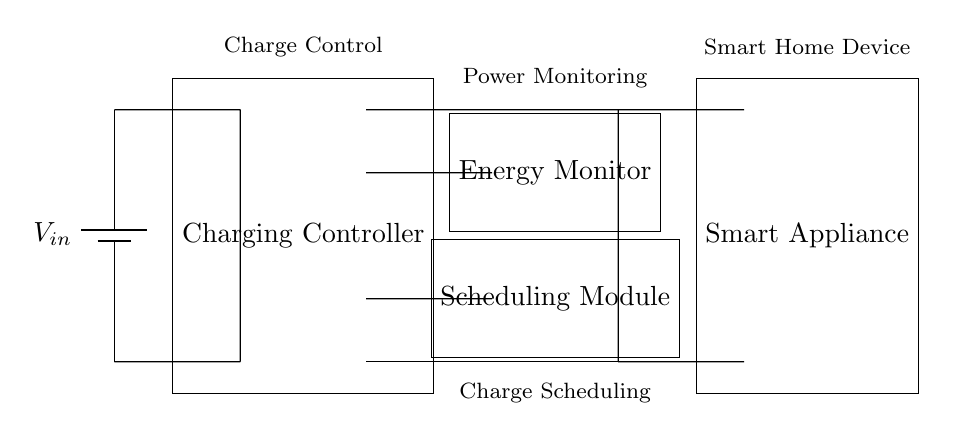What components are present in this circuit? The circuit contains a battery, charging controller, energy monitor, scheduling module, and smart appliance. Each of these components plays a specific role in the charging process and energy management.
Answer: battery, charging controller, energy monitor, scheduling module, smart appliance What is the purpose of the charging controller? The charging controller is responsible for regulating the charge to the smart appliance, ensuring that it receives the correct amount of power. This is crucial for safe and efficient charging.
Answer: regulating charge What feature does the energy monitor provide? The energy monitor tracks and reports on power usage, which helps in managing energy consumption and optimizing charging times.
Answer: power usage tracking How many short connections are there in the circuit? There are six short connections made within the circuit, linking the various components together. These connections are crucial for establishing electrical pathways.
Answer: six What is the role of the scheduling module? The scheduling module allows for the charging process to be programmed based on time or other criteria, optimizing when the appliance charges for energy efficiency.
Answer: charge scheduling Which component directly connects to the power source? The charging controller is directly connected to the power source (battery) and manages the energy flow to the smart appliance.
Answer: charging controller 